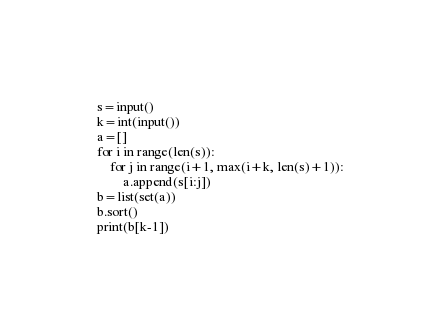<code> <loc_0><loc_0><loc_500><loc_500><_Python_>s=input()
k=int(input())
a=[]
for i in range(len(s)):
    for j in range(i+1, max(i+k, len(s)+1)):
        a.append(s[i:j])
b=list(set(a))
b.sort()
print(b[k-1])
</code> 